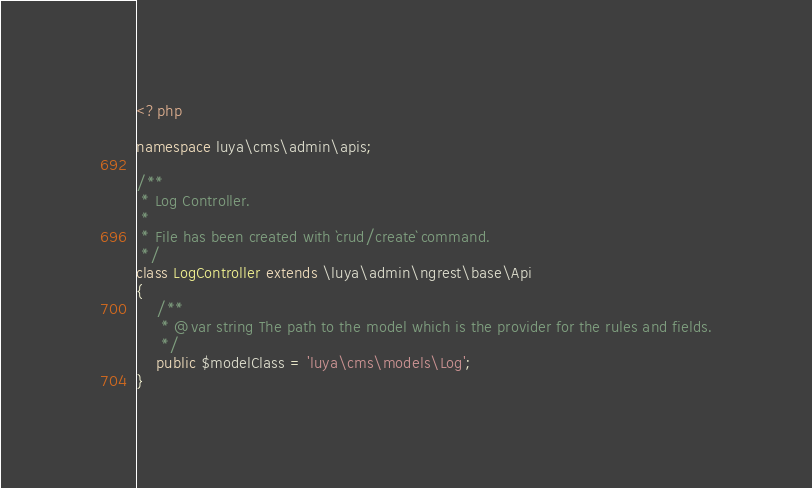Convert code to text. <code><loc_0><loc_0><loc_500><loc_500><_PHP_><?php

namespace luya\cms\admin\apis;

/**
 * Log Controller.
 * 
 * File has been created with `crud/create` command. 
 */
class LogController extends \luya\admin\ngrest\base\Api
{
    /**
     * @var string The path to the model which is the provider for the rules and fields.
     */
    public $modelClass = 'luya\cms\models\Log';
}</code> 